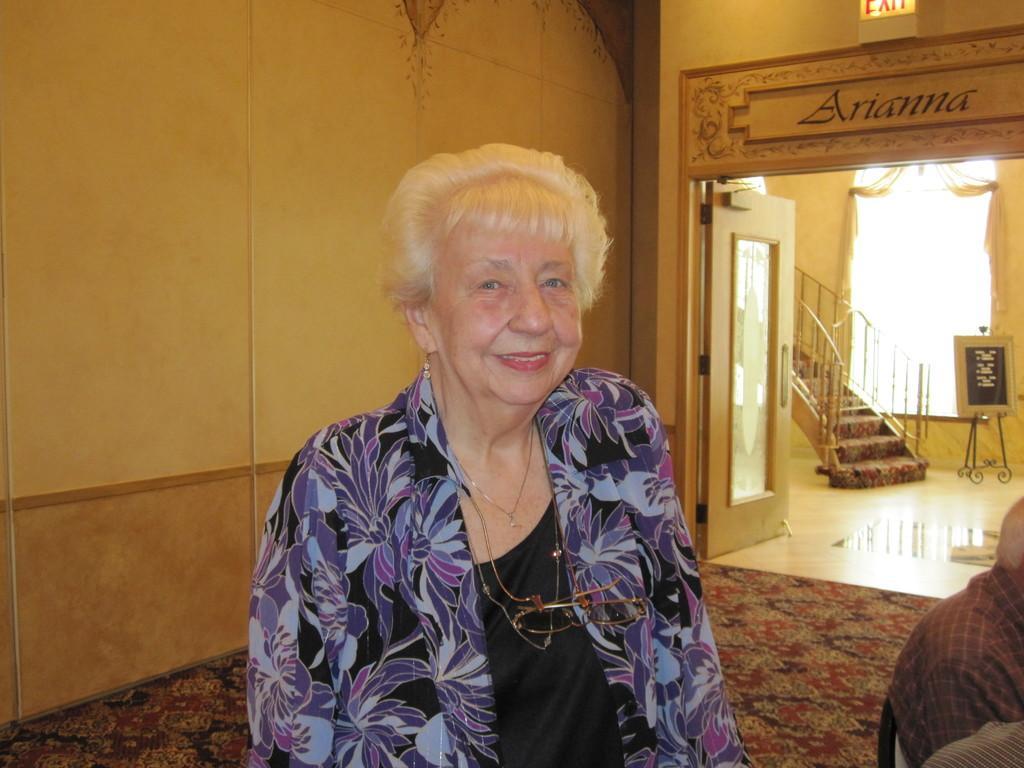Please provide a concise description of this image. In this image we can see a woman and she is smiling. In the background we can see walls, staircase, floor, carpet, door, boards, window, and a curtain. On the right side of the image we can see a person who is truncated. 